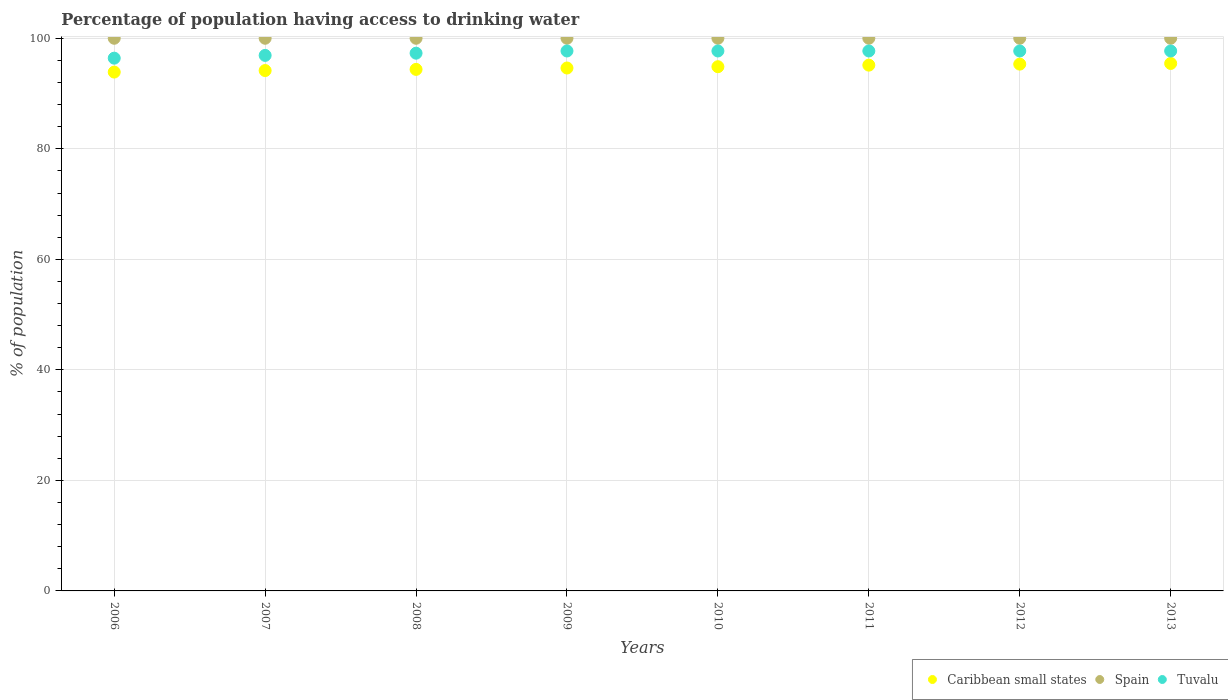How many different coloured dotlines are there?
Your answer should be very brief. 3. Is the number of dotlines equal to the number of legend labels?
Your response must be concise. Yes. What is the percentage of population having access to drinking water in Caribbean small states in 2009?
Offer a very short reply. 94.62. Across all years, what is the maximum percentage of population having access to drinking water in Caribbean small states?
Provide a succinct answer. 95.44. Across all years, what is the minimum percentage of population having access to drinking water in Tuvalu?
Offer a terse response. 96.4. In which year was the percentage of population having access to drinking water in Spain maximum?
Offer a very short reply. 2006. In which year was the percentage of population having access to drinking water in Spain minimum?
Provide a succinct answer. 2006. What is the total percentage of population having access to drinking water in Caribbean small states in the graph?
Ensure brevity in your answer.  757.78. What is the difference between the percentage of population having access to drinking water in Caribbean small states in 2008 and that in 2013?
Your answer should be very brief. -1.07. What is the difference between the percentage of population having access to drinking water in Caribbean small states in 2012 and the percentage of population having access to drinking water in Spain in 2010?
Offer a very short reply. -4.68. What is the average percentage of population having access to drinking water in Caribbean small states per year?
Provide a succinct answer. 94.72. In the year 2009, what is the difference between the percentage of population having access to drinking water in Tuvalu and percentage of population having access to drinking water in Caribbean small states?
Your response must be concise. 3.08. What is the ratio of the percentage of population having access to drinking water in Spain in 2010 to that in 2012?
Ensure brevity in your answer.  1. What is the difference between the highest and the second highest percentage of population having access to drinking water in Caribbean small states?
Provide a succinct answer. 0.12. In how many years, is the percentage of population having access to drinking water in Spain greater than the average percentage of population having access to drinking water in Spain taken over all years?
Provide a short and direct response. 0. Is the sum of the percentage of population having access to drinking water in Tuvalu in 2008 and 2011 greater than the maximum percentage of population having access to drinking water in Caribbean small states across all years?
Make the answer very short. Yes. Does the percentage of population having access to drinking water in Spain monotonically increase over the years?
Provide a short and direct response. No. Is the percentage of population having access to drinking water in Tuvalu strictly less than the percentage of population having access to drinking water in Spain over the years?
Offer a terse response. Yes. How many dotlines are there?
Make the answer very short. 3. What is the difference between two consecutive major ticks on the Y-axis?
Your answer should be compact. 20. Does the graph contain grids?
Keep it short and to the point. Yes. Where does the legend appear in the graph?
Ensure brevity in your answer.  Bottom right. How many legend labels are there?
Your answer should be compact. 3. What is the title of the graph?
Offer a terse response. Percentage of population having access to drinking water. Does "South Asia" appear as one of the legend labels in the graph?
Your response must be concise. No. What is the label or title of the X-axis?
Offer a terse response. Years. What is the label or title of the Y-axis?
Offer a very short reply. % of population. What is the % of population of Caribbean small states in 2006?
Your answer should be compact. 93.88. What is the % of population in Tuvalu in 2006?
Offer a terse response. 96.4. What is the % of population in Caribbean small states in 2007?
Your answer should be compact. 94.16. What is the % of population of Spain in 2007?
Offer a very short reply. 100. What is the % of population of Tuvalu in 2007?
Provide a short and direct response. 96.9. What is the % of population of Caribbean small states in 2008?
Ensure brevity in your answer.  94.37. What is the % of population in Tuvalu in 2008?
Offer a very short reply. 97.3. What is the % of population in Caribbean small states in 2009?
Offer a terse response. 94.62. What is the % of population of Tuvalu in 2009?
Your answer should be compact. 97.7. What is the % of population of Caribbean small states in 2010?
Provide a short and direct response. 94.85. What is the % of population in Spain in 2010?
Provide a short and direct response. 100. What is the % of population of Tuvalu in 2010?
Offer a very short reply. 97.7. What is the % of population of Caribbean small states in 2011?
Make the answer very short. 95.14. What is the % of population of Tuvalu in 2011?
Give a very brief answer. 97.7. What is the % of population in Caribbean small states in 2012?
Offer a terse response. 95.32. What is the % of population in Spain in 2012?
Your answer should be compact. 100. What is the % of population of Tuvalu in 2012?
Your response must be concise. 97.7. What is the % of population in Caribbean small states in 2013?
Make the answer very short. 95.44. What is the % of population of Spain in 2013?
Ensure brevity in your answer.  100. What is the % of population in Tuvalu in 2013?
Offer a very short reply. 97.7. Across all years, what is the maximum % of population of Caribbean small states?
Ensure brevity in your answer.  95.44. Across all years, what is the maximum % of population in Tuvalu?
Your answer should be very brief. 97.7. Across all years, what is the minimum % of population in Caribbean small states?
Provide a succinct answer. 93.88. Across all years, what is the minimum % of population of Spain?
Offer a very short reply. 100. Across all years, what is the minimum % of population of Tuvalu?
Keep it short and to the point. 96.4. What is the total % of population of Caribbean small states in the graph?
Keep it short and to the point. 757.78. What is the total % of population in Spain in the graph?
Keep it short and to the point. 800. What is the total % of population in Tuvalu in the graph?
Offer a terse response. 779.1. What is the difference between the % of population in Caribbean small states in 2006 and that in 2007?
Give a very brief answer. -0.28. What is the difference between the % of population in Spain in 2006 and that in 2007?
Ensure brevity in your answer.  0. What is the difference between the % of population of Caribbean small states in 2006 and that in 2008?
Your answer should be compact. -0.49. What is the difference between the % of population of Caribbean small states in 2006 and that in 2009?
Your answer should be very brief. -0.74. What is the difference between the % of population of Caribbean small states in 2006 and that in 2010?
Offer a very short reply. -0.97. What is the difference between the % of population of Caribbean small states in 2006 and that in 2011?
Give a very brief answer. -1.26. What is the difference between the % of population in Spain in 2006 and that in 2011?
Ensure brevity in your answer.  0. What is the difference between the % of population in Tuvalu in 2006 and that in 2011?
Provide a short and direct response. -1.3. What is the difference between the % of population of Caribbean small states in 2006 and that in 2012?
Your answer should be compact. -1.44. What is the difference between the % of population in Spain in 2006 and that in 2012?
Make the answer very short. 0. What is the difference between the % of population in Caribbean small states in 2006 and that in 2013?
Offer a terse response. -1.56. What is the difference between the % of population of Spain in 2006 and that in 2013?
Your answer should be very brief. 0. What is the difference between the % of population in Caribbean small states in 2007 and that in 2008?
Offer a very short reply. -0.21. What is the difference between the % of population of Spain in 2007 and that in 2008?
Your answer should be very brief. 0. What is the difference between the % of population in Caribbean small states in 2007 and that in 2009?
Your answer should be very brief. -0.46. What is the difference between the % of population of Spain in 2007 and that in 2009?
Offer a very short reply. 0. What is the difference between the % of population of Tuvalu in 2007 and that in 2009?
Offer a terse response. -0.8. What is the difference between the % of population of Caribbean small states in 2007 and that in 2010?
Provide a short and direct response. -0.7. What is the difference between the % of population in Spain in 2007 and that in 2010?
Make the answer very short. 0. What is the difference between the % of population of Caribbean small states in 2007 and that in 2011?
Your answer should be very brief. -0.98. What is the difference between the % of population of Caribbean small states in 2007 and that in 2012?
Offer a terse response. -1.16. What is the difference between the % of population in Tuvalu in 2007 and that in 2012?
Offer a very short reply. -0.8. What is the difference between the % of population in Caribbean small states in 2007 and that in 2013?
Ensure brevity in your answer.  -1.28. What is the difference between the % of population of Spain in 2007 and that in 2013?
Offer a terse response. 0. What is the difference between the % of population of Tuvalu in 2007 and that in 2013?
Your answer should be very brief. -0.8. What is the difference between the % of population of Caribbean small states in 2008 and that in 2009?
Offer a very short reply. -0.25. What is the difference between the % of population of Tuvalu in 2008 and that in 2009?
Ensure brevity in your answer.  -0.4. What is the difference between the % of population in Caribbean small states in 2008 and that in 2010?
Offer a terse response. -0.49. What is the difference between the % of population in Spain in 2008 and that in 2010?
Provide a succinct answer. 0. What is the difference between the % of population in Caribbean small states in 2008 and that in 2011?
Keep it short and to the point. -0.77. What is the difference between the % of population of Spain in 2008 and that in 2011?
Offer a very short reply. 0. What is the difference between the % of population of Caribbean small states in 2008 and that in 2012?
Your response must be concise. -0.95. What is the difference between the % of population of Spain in 2008 and that in 2012?
Provide a short and direct response. 0. What is the difference between the % of population of Tuvalu in 2008 and that in 2012?
Make the answer very short. -0.4. What is the difference between the % of population of Caribbean small states in 2008 and that in 2013?
Provide a short and direct response. -1.07. What is the difference between the % of population of Caribbean small states in 2009 and that in 2010?
Offer a very short reply. -0.24. What is the difference between the % of population of Spain in 2009 and that in 2010?
Your response must be concise. 0. What is the difference between the % of population of Tuvalu in 2009 and that in 2010?
Make the answer very short. 0. What is the difference between the % of population of Caribbean small states in 2009 and that in 2011?
Your response must be concise. -0.52. What is the difference between the % of population of Spain in 2009 and that in 2011?
Ensure brevity in your answer.  0. What is the difference between the % of population in Caribbean small states in 2009 and that in 2012?
Provide a short and direct response. -0.7. What is the difference between the % of population of Tuvalu in 2009 and that in 2012?
Make the answer very short. 0. What is the difference between the % of population in Caribbean small states in 2009 and that in 2013?
Ensure brevity in your answer.  -0.82. What is the difference between the % of population of Tuvalu in 2009 and that in 2013?
Give a very brief answer. 0. What is the difference between the % of population in Caribbean small states in 2010 and that in 2011?
Provide a succinct answer. -0.28. What is the difference between the % of population in Spain in 2010 and that in 2011?
Provide a succinct answer. 0. What is the difference between the % of population of Caribbean small states in 2010 and that in 2012?
Ensure brevity in your answer.  -0.47. What is the difference between the % of population in Spain in 2010 and that in 2012?
Offer a very short reply. 0. What is the difference between the % of population of Tuvalu in 2010 and that in 2012?
Ensure brevity in your answer.  0. What is the difference between the % of population in Caribbean small states in 2010 and that in 2013?
Offer a terse response. -0.59. What is the difference between the % of population in Tuvalu in 2010 and that in 2013?
Your answer should be compact. 0. What is the difference between the % of population in Caribbean small states in 2011 and that in 2012?
Keep it short and to the point. -0.18. What is the difference between the % of population of Spain in 2011 and that in 2012?
Your answer should be very brief. 0. What is the difference between the % of population in Caribbean small states in 2011 and that in 2013?
Provide a succinct answer. -0.3. What is the difference between the % of population in Tuvalu in 2011 and that in 2013?
Give a very brief answer. 0. What is the difference between the % of population in Caribbean small states in 2012 and that in 2013?
Keep it short and to the point. -0.12. What is the difference between the % of population of Spain in 2012 and that in 2013?
Provide a short and direct response. 0. What is the difference between the % of population of Caribbean small states in 2006 and the % of population of Spain in 2007?
Make the answer very short. -6.12. What is the difference between the % of population in Caribbean small states in 2006 and the % of population in Tuvalu in 2007?
Ensure brevity in your answer.  -3.02. What is the difference between the % of population of Spain in 2006 and the % of population of Tuvalu in 2007?
Your response must be concise. 3.1. What is the difference between the % of population of Caribbean small states in 2006 and the % of population of Spain in 2008?
Make the answer very short. -6.12. What is the difference between the % of population in Caribbean small states in 2006 and the % of population in Tuvalu in 2008?
Ensure brevity in your answer.  -3.42. What is the difference between the % of population of Spain in 2006 and the % of population of Tuvalu in 2008?
Make the answer very short. 2.7. What is the difference between the % of population in Caribbean small states in 2006 and the % of population in Spain in 2009?
Provide a succinct answer. -6.12. What is the difference between the % of population of Caribbean small states in 2006 and the % of population of Tuvalu in 2009?
Give a very brief answer. -3.82. What is the difference between the % of population of Caribbean small states in 2006 and the % of population of Spain in 2010?
Offer a terse response. -6.12. What is the difference between the % of population in Caribbean small states in 2006 and the % of population in Tuvalu in 2010?
Ensure brevity in your answer.  -3.82. What is the difference between the % of population of Caribbean small states in 2006 and the % of population of Spain in 2011?
Offer a terse response. -6.12. What is the difference between the % of population of Caribbean small states in 2006 and the % of population of Tuvalu in 2011?
Ensure brevity in your answer.  -3.82. What is the difference between the % of population of Spain in 2006 and the % of population of Tuvalu in 2011?
Your answer should be compact. 2.3. What is the difference between the % of population of Caribbean small states in 2006 and the % of population of Spain in 2012?
Offer a terse response. -6.12. What is the difference between the % of population in Caribbean small states in 2006 and the % of population in Tuvalu in 2012?
Give a very brief answer. -3.82. What is the difference between the % of population of Spain in 2006 and the % of population of Tuvalu in 2012?
Provide a short and direct response. 2.3. What is the difference between the % of population in Caribbean small states in 2006 and the % of population in Spain in 2013?
Make the answer very short. -6.12. What is the difference between the % of population in Caribbean small states in 2006 and the % of population in Tuvalu in 2013?
Ensure brevity in your answer.  -3.82. What is the difference between the % of population in Caribbean small states in 2007 and the % of population in Spain in 2008?
Keep it short and to the point. -5.84. What is the difference between the % of population of Caribbean small states in 2007 and the % of population of Tuvalu in 2008?
Your response must be concise. -3.14. What is the difference between the % of population of Caribbean small states in 2007 and the % of population of Spain in 2009?
Your answer should be very brief. -5.84. What is the difference between the % of population in Caribbean small states in 2007 and the % of population in Tuvalu in 2009?
Offer a terse response. -3.54. What is the difference between the % of population in Caribbean small states in 2007 and the % of population in Spain in 2010?
Keep it short and to the point. -5.84. What is the difference between the % of population of Caribbean small states in 2007 and the % of population of Tuvalu in 2010?
Your answer should be compact. -3.54. What is the difference between the % of population in Spain in 2007 and the % of population in Tuvalu in 2010?
Keep it short and to the point. 2.3. What is the difference between the % of population of Caribbean small states in 2007 and the % of population of Spain in 2011?
Offer a very short reply. -5.84. What is the difference between the % of population of Caribbean small states in 2007 and the % of population of Tuvalu in 2011?
Ensure brevity in your answer.  -3.54. What is the difference between the % of population of Spain in 2007 and the % of population of Tuvalu in 2011?
Give a very brief answer. 2.3. What is the difference between the % of population of Caribbean small states in 2007 and the % of population of Spain in 2012?
Give a very brief answer. -5.84. What is the difference between the % of population of Caribbean small states in 2007 and the % of population of Tuvalu in 2012?
Your answer should be compact. -3.54. What is the difference between the % of population in Spain in 2007 and the % of population in Tuvalu in 2012?
Provide a short and direct response. 2.3. What is the difference between the % of population of Caribbean small states in 2007 and the % of population of Spain in 2013?
Your answer should be very brief. -5.84. What is the difference between the % of population in Caribbean small states in 2007 and the % of population in Tuvalu in 2013?
Keep it short and to the point. -3.54. What is the difference between the % of population in Spain in 2007 and the % of population in Tuvalu in 2013?
Offer a terse response. 2.3. What is the difference between the % of population in Caribbean small states in 2008 and the % of population in Spain in 2009?
Make the answer very short. -5.63. What is the difference between the % of population of Caribbean small states in 2008 and the % of population of Tuvalu in 2009?
Provide a succinct answer. -3.33. What is the difference between the % of population of Caribbean small states in 2008 and the % of population of Spain in 2010?
Ensure brevity in your answer.  -5.63. What is the difference between the % of population in Caribbean small states in 2008 and the % of population in Tuvalu in 2010?
Your answer should be very brief. -3.33. What is the difference between the % of population of Caribbean small states in 2008 and the % of population of Spain in 2011?
Ensure brevity in your answer.  -5.63. What is the difference between the % of population in Caribbean small states in 2008 and the % of population in Tuvalu in 2011?
Your response must be concise. -3.33. What is the difference between the % of population in Caribbean small states in 2008 and the % of population in Spain in 2012?
Give a very brief answer. -5.63. What is the difference between the % of population in Caribbean small states in 2008 and the % of population in Tuvalu in 2012?
Offer a very short reply. -3.33. What is the difference between the % of population in Spain in 2008 and the % of population in Tuvalu in 2012?
Ensure brevity in your answer.  2.3. What is the difference between the % of population of Caribbean small states in 2008 and the % of population of Spain in 2013?
Offer a terse response. -5.63. What is the difference between the % of population in Caribbean small states in 2008 and the % of population in Tuvalu in 2013?
Your response must be concise. -3.33. What is the difference between the % of population of Spain in 2008 and the % of population of Tuvalu in 2013?
Your answer should be very brief. 2.3. What is the difference between the % of population in Caribbean small states in 2009 and the % of population in Spain in 2010?
Offer a terse response. -5.38. What is the difference between the % of population in Caribbean small states in 2009 and the % of population in Tuvalu in 2010?
Offer a very short reply. -3.08. What is the difference between the % of population in Spain in 2009 and the % of population in Tuvalu in 2010?
Ensure brevity in your answer.  2.3. What is the difference between the % of population of Caribbean small states in 2009 and the % of population of Spain in 2011?
Your answer should be very brief. -5.38. What is the difference between the % of population in Caribbean small states in 2009 and the % of population in Tuvalu in 2011?
Provide a short and direct response. -3.08. What is the difference between the % of population in Caribbean small states in 2009 and the % of population in Spain in 2012?
Your answer should be very brief. -5.38. What is the difference between the % of population of Caribbean small states in 2009 and the % of population of Tuvalu in 2012?
Provide a succinct answer. -3.08. What is the difference between the % of population of Spain in 2009 and the % of population of Tuvalu in 2012?
Give a very brief answer. 2.3. What is the difference between the % of population of Caribbean small states in 2009 and the % of population of Spain in 2013?
Provide a short and direct response. -5.38. What is the difference between the % of population of Caribbean small states in 2009 and the % of population of Tuvalu in 2013?
Your answer should be compact. -3.08. What is the difference between the % of population of Caribbean small states in 2010 and the % of population of Spain in 2011?
Provide a succinct answer. -5.15. What is the difference between the % of population of Caribbean small states in 2010 and the % of population of Tuvalu in 2011?
Keep it short and to the point. -2.85. What is the difference between the % of population of Caribbean small states in 2010 and the % of population of Spain in 2012?
Give a very brief answer. -5.15. What is the difference between the % of population in Caribbean small states in 2010 and the % of population in Tuvalu in 2012?
Keep it short and to the point. -2.85. What is the difference between the % of population of Caribbean small states in 2010 and the % of population of Spain in 2013?
Provide a succinct answer. -5.15. What is the difference between the % of population of Caribbean small states in 2010 and the % of population of Tuvalu in 2013?
Give a very brief answer. -2.85. What is the difference between the % of population in Spain in 2010 and the % of population in Tuvalu in 2013?
Make the answer very short. 2.3. What is the difference between the % of population in Caribbean small states in 2011 and the % of population in Spain in 2012?
Provide a short and direct response. -4.86. What is the difference between the % of population of Caribbean small states in 2011 and the % of population of Tuvalu in 2012?
Your response must be concise. -2.56. What is the difference between the % of population of Caribbean small states in 2011 and the % of population of Spain in 2013?
Provide a short and direct response. -4.86. What is the difference between the % of population of Caribbean small states in 2011 and the % of population of Tuvalu in 2013?
Your answer should be compact. -2.56. What is the difference between the % of population of Spain in 2011 and the % of population of Tuvalu in 2013?
Offer a very short reply. 2.3. What is the difference between the % of population of Caribbean small states in 2012 and the % of population of Spain in 2013?
Your answer should be very brief. -4.68. What is the difference between the % of population of Caribbean small states in 2012 and the % of population of Tuvalu in 2013?
Your answer should be compact. -2.38. What is the average % of population of Caribbean small states per year?
Your answer should be compact. 94.72. What is the average % of population in Tuvalu per year?
Your answer should be compact. 97.39. In the year 2006, what is the difference between the % of population of Caribbean small states and % of population of Spain?
Your response must be concise. -6.12. In the year 2006, what is the difference between the % of population in Caribbean small states and % of population in Tuvalu?
Provide a succinct answer. -2.52. In the year 2006, what is the difference between the % of population in Spain and % of population in Tuvalu?
Your answer should be compact. 3.6. In the year 2007, what is the difference between the % of population of Caribbean small states and % of population of Spain?
Your response must be concise. -5.84. In the year 2007, what is the difference between the % of population of Caribbean small states and % of population of Tuvalu?
Provide a succinct answer. -2.74. In the year 2007, what is the difference between the % of population in Spain and % of population in Tuvalu?
Your response must be concise. 3.1. In the year 2008, what is the difference between the % of population of Caribbean small states and % of population of Spain?
Provide a succinct answer. -5.63. In the year 2008, what is the difference between the % of population of Caribbean small states and % of population of Tuvalu?
Provide a succinct answer. -2.93. In the year 2009, what is the difference between the % of population in Caribbean small states and % of population in Spain?
Keep it short and to the point. -5.38. In the year 2009, what is the difference between the % of population of Caribbean small states and % of population of Tuvalu?
Ensure brevity in your answer.  -3.08. In the year 2010, what is the difference between the % of population in Caribbean small states and % of population in Spain?
Your answer should be very brief. -5.15. In the year 2010, what is the difference between the % of population in Caribbean small states and % of population in Tuvalu?
Your answer should be very brief. -2.85. In the year 2010, what is the difference between the % of population in Spain and % of population in Tuvalu?
Make the answer very short. 2.3. In the year 2011, what is the difference between the % of population in Caribbean small states and % of population in Spain?
Provide a succinct answer. -4.86. In the year 2011, what is the difference between the % of population of Caribbean small states and % of population of Tuvalu?
Provide a short and direct response. -2.56. In the year 2012, what is the difference between the % of population in Caribbean small states and % of population in Spain?
Your answer should be very brief. -4.68. In the year 2012, what is the difference between the % of population in Caribbean small states and % of population in Tuvalu?
Give a very brief answer. -2.38. In the year 2012, what is the difference between the % of population in Spain and % of population in Tuvalu?
Your answer should be compact. 2.3. In the year 2013, what is the difference between the % of population of Caribbean small states and % of population of Spain?
Provide a succinct answer. -4.56. In the year 2013, what is the difference between the % of population of Caribbean small states and % of population of Tuvalu?
Give a very brief answer. -2.26. In the year 2013, what is the difference between the % of population in Spain and % of population in Tuvalu?
Make the answer very short. 2.3. What is the ratio of the % of population in Caribbean small states in 2006 to that in 2007?
Give a very brief answer. 1. What is the ratio of the % of population of Caribbean small states in 2006 to that in 2008?
Offer a terse response. 0.99. What is the ratio of the % of population in Tuvalu in 2006 to that in 2009?
Offer a terse response. 0.99. What is the ratio of the % of population in Caribbean small states in 2006 to that in 2010?
Your answer should be very brief. 0.99. What is the ratio of the % of population of Spain in 2006 to that in 2010?
Keep it short and to the point. 1. What is the ratio of the % of population in Tuvalu in 2006 to that in 2010?
Offer a very short reply. 0.99. What is the ratio of the % of population in Caribbean small states in 2006 to that in 2011?
Keep it short and to the point. 0.99. What is the ratio of the % of population of Tuvalu in 2006 to that in 2011?
Provide a short and direct response. 0.99. What is the ratio of the % of population in Caribbean small states in 2006 to that in 2012?
Offer a terse response. 0.98. What is the ratio of the % of population in Spain in 2006 to that in 2012?
Your response must be concise. 1. What is the ratio of the % of population of Tuvalu in 2006 to that in 2012?
Offer a very short reply. 0.99. What is the ratio of the % of population in Caribbean small states in 2006 to that in 2013?
Offer a terse response. 0.98. What is the ratio of the % of population in Tuvalu in 2006 to that in 2013?
Ensure brevity in your answer.  0.99. What is the ratio of the % of population of Caribbean small states in 2007 to that in 2008?
Keep it short and to the point. 1. What is the ratio of the % of population in Spain in 2007 to that in 2008?
Provide a succinct answer. 1. What is the ratio of the % of population in Tuvalu in 2007 to that in 2008?
Your answer should be very brief. 1. What is the ratio of the % of population in Spain in 2007 to that in 2009?
Your response must be concise. 1. What is the ratio of the % of population of Tuvalu in 2007 to that in 2009?
Your answer should be very brief. 0.99. What is the ratio of the % of population in Caribbean small states in 2007 to that in 2010?
Make the answer very short. 0.99. What is the ratio of the % of population of Spain in 2007 to that in 2010?
Offer a very short reply. 1. What is the ratio of the % of population in Caribbean small states in 2007 to that in 2011?
Provide a short and direct response. 0.99. What is the ratio of the % of population in Spain in 2007 to that in 2012?
Offer a terse response. 1. What is the ratio of the % of population of Tuvalu in 2007 to that in 2012?
Offer a very short reply. 0.99. What is the ratio of the % of population in Caribbean small states in 2007 to that in 2013?
Give a very brief answer. 0.99. What is the ratio of the % of population in Caribbean small states in 2008 to that in 2009?
Keep it short and to the point. 1. What is the ratio of the % of population of Tuvalu in 2008 to that in 2009?
Your response must be concise. 1. What is the ratio of the % of population of Caribbean small states in 2008 to that in 2010?
Your answer should be very brief. 0.99. What is the ratio of the % of population of Spain in 2008 to that in 2010?
Provide a succinct answer. 1. What is the ratio of the % of population in Tuvalu in 2008 to that in 2011?
Offer a very short reply. 1. What is the ratio of the % of population in Tuvalu in 2008 to that in 2012?
Keep it short and to the point. 1. What is the ratio of the % of population in Tuvalu in 2008 to that in 2013?
Your response must be concise. 1. What is the ratio of the % of population of Caribbean small states in 2009 to that in 2010?
Your answer should be compact. 1. What is the ratio of the % of population of Spain in 2009 to that in 2010?
Provide a succinct answer. 1. What is the ratio of the % of population of Spain in 2009 to that in 2011?
Offer a very short reply. 1. What is the ratio of the % of population of Tuvalu in 2009 to that in 2011?
Your answer should be very brief. 1. What is the ratio of the % of population in Caribbean small states in 2009 to that in 2012?
Your answer should be very brief. 0.99. What is the ratio of the % of population in Spain in 2009 to that in 2012?
Your answer should be compact. 1. What is the ratio of the % of population of Caribbean small states in 2009 to that in 2013?
Your response must be concise. 0.99. What is the ratio of the % of population of Tuvalu in 2009 to that in 2013?
Your answer should be very brief. 1. What is the ratio of the % of population in Caribbean small states in 2010 to that in 2011?
Offer a very short reply. 1. What is the ratio of the % of population in Tuvalu in 2010 to that in 2011?
Keep it short and to the point. 1. What is the ratio of the % of population in Spain in 2010 to that in 2012?
Provide a succinct answer. 1. What is the ratio of the % of population in Caribbean small states in 2010 to that in 2013?
Make the answer very short. 0.99. What is the ratio of the % of population of Tuvalu in 2010 to that in 2013?
Provide a short and direct response. 1. What is the ratio of the % of population of Tuvalu in 2011 to that in 2012?
Make the answer very short. 1. What is the ratio of the % of population of Caribbean small states in 2011 to that in 2013?
Provide a short and direct response. 1. What is the ratio of the % of population of Caribbean small states in 2012 to that in 2013?
Give a very brief answer. 1. What is the ratio of the % of population in Tuvalu in 2012 to that in 2013?
Your response must be concise. 1. What is the difference between the highest and the second highest % of population in Caribbean small states?
Give a very brief answer. 0.12. What is the difference between the highest and the second highest % of population in Spain?
Provide a succinct answer. 0. What is the difference between the highest and the lowest % of population in Caribbean small states?
Offer a terse response. 1.56. 